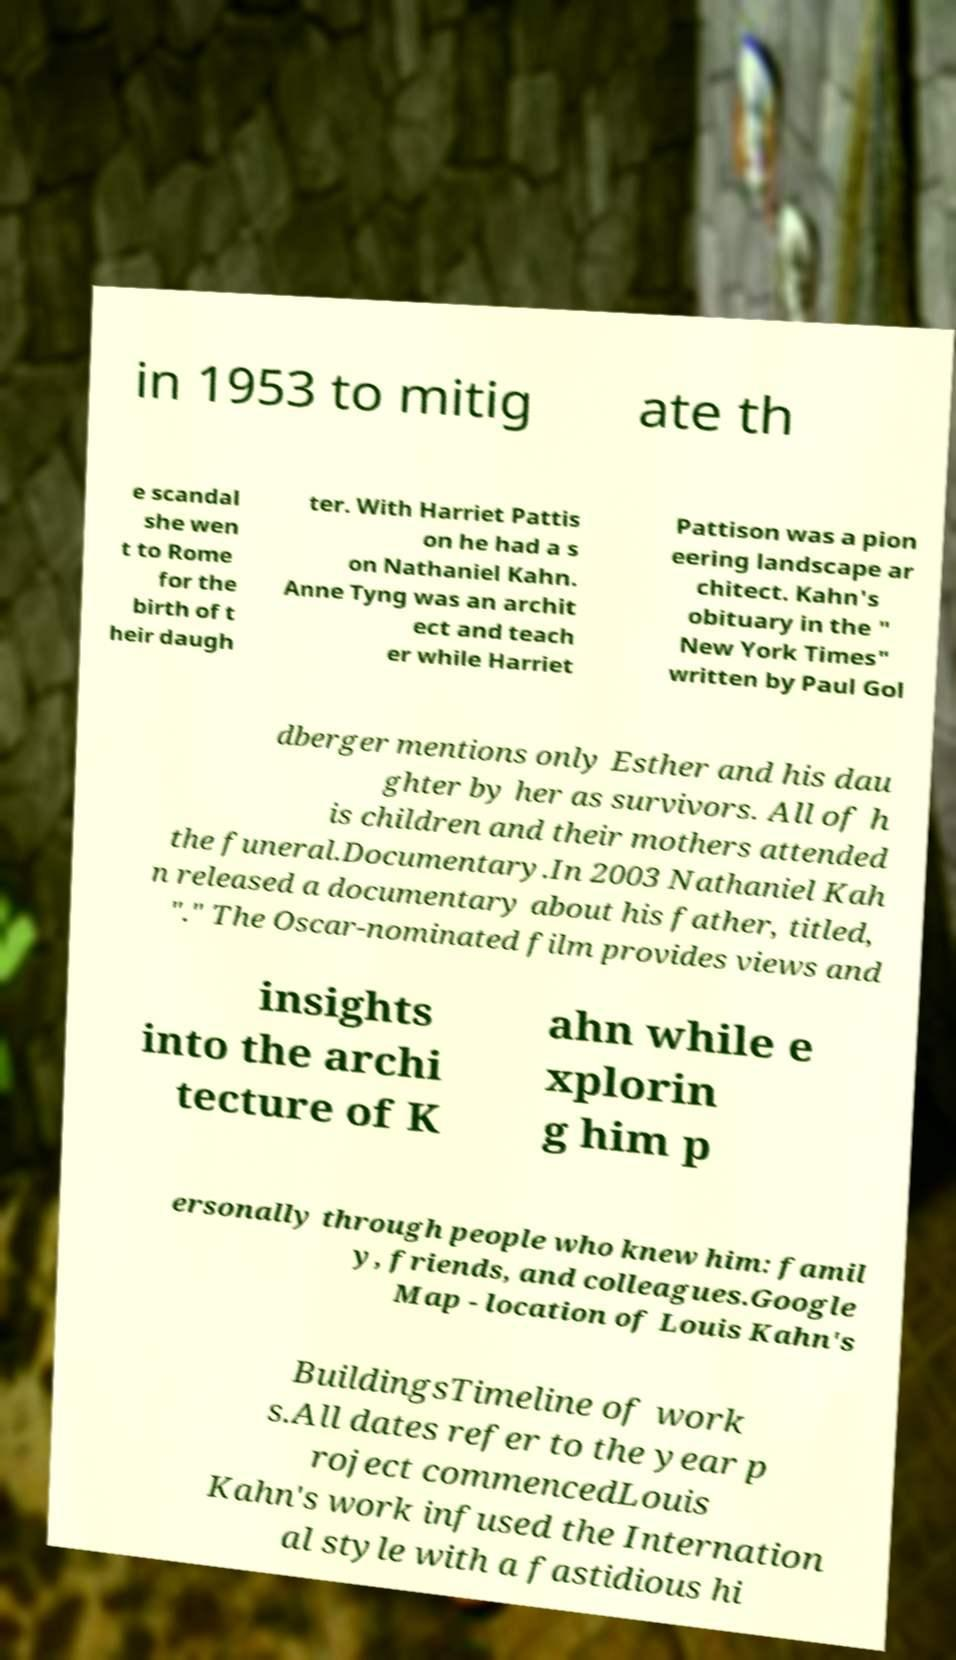There's text embedded in this image that I need extracted. Can you transcribe it verbatim? in 1953 to mitig ate th e scandal she wen t to Rome for the birth of t heir daugh ter. With Harriet Pattis on he had a s on Nathaniel Kahn. Anne Tyng was an archit ect and teach er while Harriet Pattison was a pion eering landscape ar chitect. Kahn's obituary in the " New York Times" written by Paul Gol dberger mentions only Esther and his dau ghter by her as survivors. All of h is children and their mothers attended the funeral.Documentary.In 2003 Nathaniel Kah n released a documentary about his father, titled, "." The Oscar-nominated film provides views and insights into the archi tecture of K ahn while e xplorin g him p ersonally through people who knew him: famil y, friends, and colleagues.Google Map - location of Louis Kahn's BuildingsTimeline of work s.All dates refer to the year p roject commencedLouis Kahn's work infused the Internation al style with a fastidious hi 